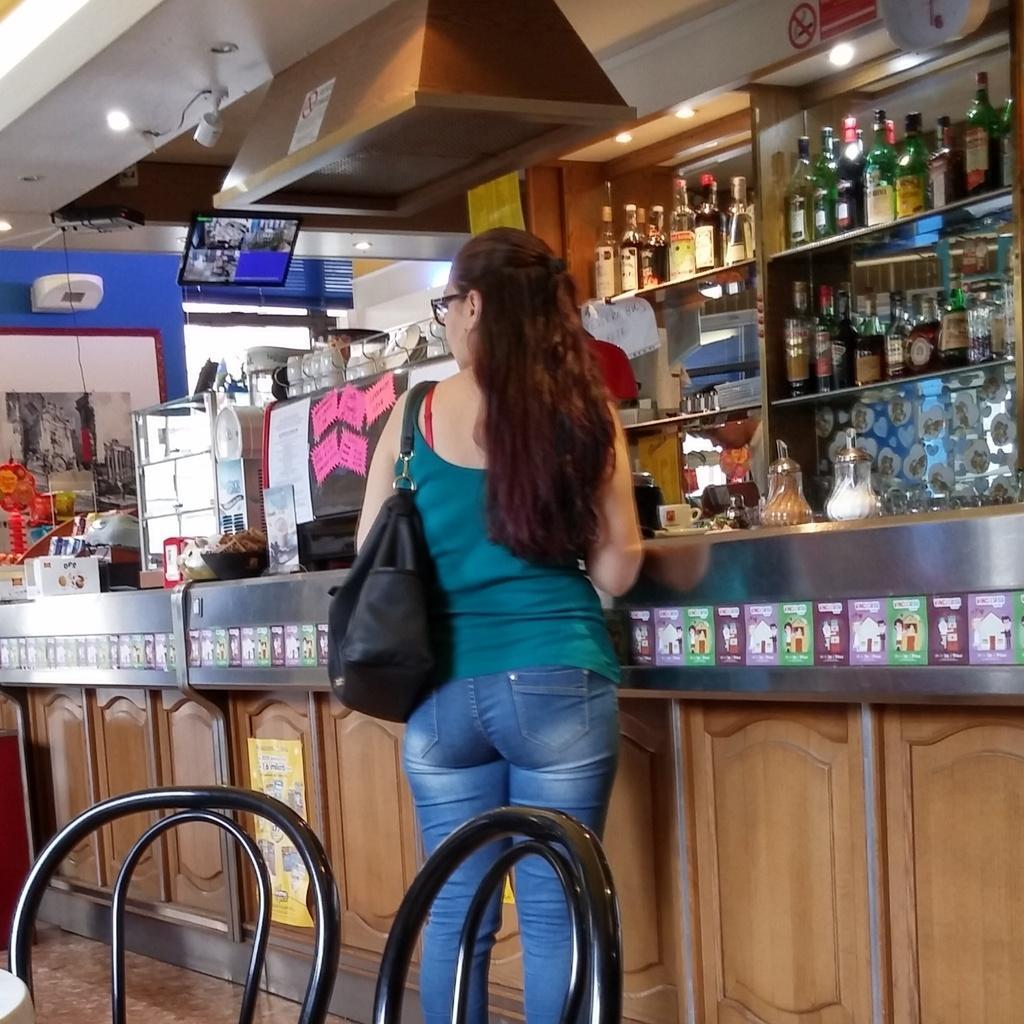Please provide a concise description of this image. In this picture, we can see a woman standing on the floor and behind the woman there are chairs and in front of the woman there are some objects on the platform and in the shelves there are different kinds of bottles and there are ceiling lights on the top and a screen. 